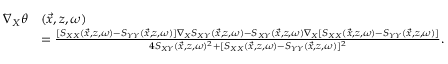<formula> <loc_0><loc_0><loc_500><loc_500>\begin{array} { r l } { \nabla _ { X } \theta } & { ( \vec { x } , z , \omega ) } \\ & { = \frac { [ S _ { X X } ( \vec { x } , z , \omega ) - S _ { Y Y } ( \vec { x } , z , \omega ) ] \nabla _ { X } S _ { X Y } ( \vec { x } , z , \omega ) - S _ { X Y } ( \vec { x } , z , \omega ) \nabla _ { X } [ S _ { X X } ( \vec { x } , z , \omega ) - S _ { Y Y } ( \vec { x } , z , \omega ) ] } { 4 S _ { X Y } ( \vec { x } , z , \omega ) ^ { 2 } + [ S _ { X X } ( \vec { x } , z , \omega ) - S _ { Y Y } ( \vec { x } , z , \omega ) ] ^ { 2 } } . } \end{array}</formula> 